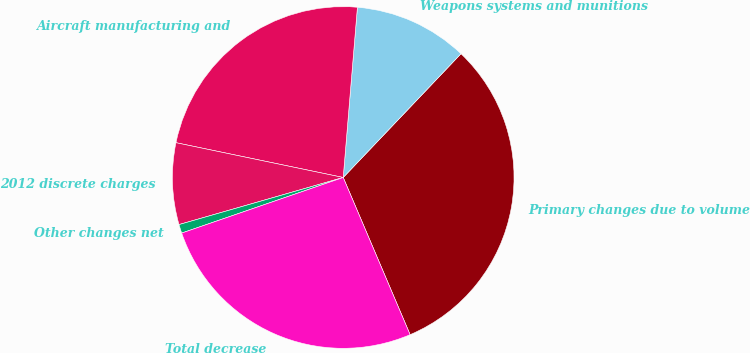<chart> <loc_0><loc_0><loc_500><loc_500><pie_chart><fcel>Primary changes due to volume<fcel>Weapons systems and munitions<fcel>Aircraft manufacturing and<fcel>2012 discrete charges<fcel>Other changes net<fcel>Total decrease<nl><fcel>31.49%<fcel>10.78%<fcel>23.06%<fcel>7.71%<fcel>0.83%<fcel>26.13%<nl></chart> 